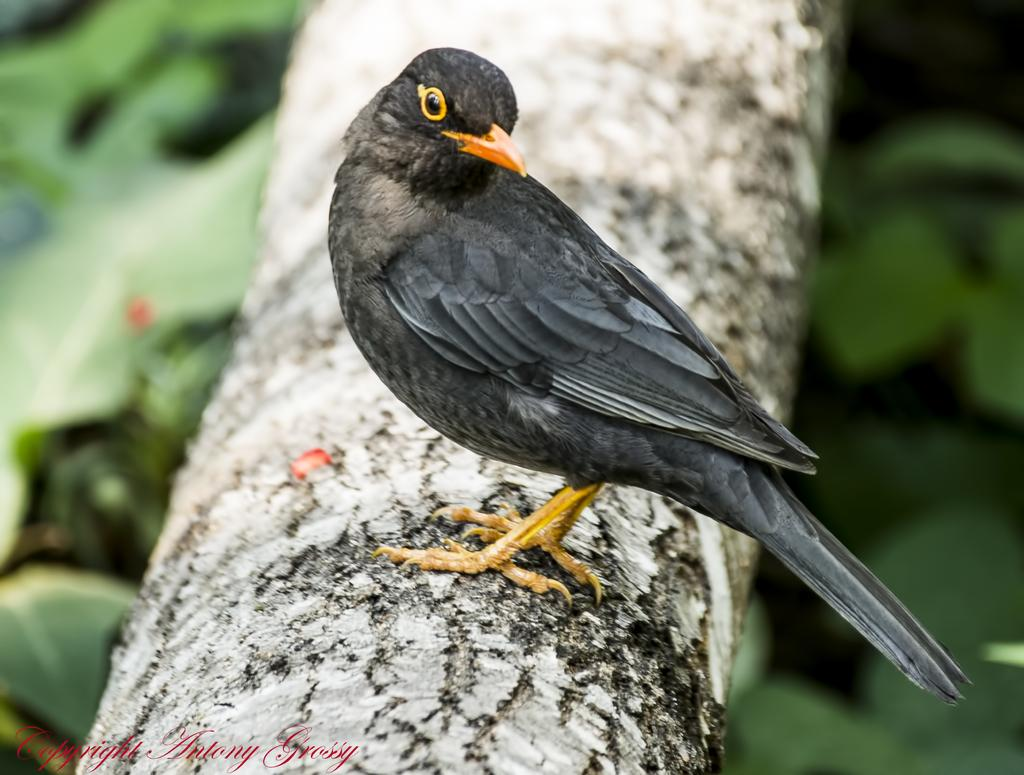What type of animal can be seen in the image? There is a bird in the image. Where is the bird located? The bird is on a log. What color is the background of the image? The background of the image is blue. What type of vegetation can be seen in the background? There is greenery in the background of the image. Reasoning: Let'g: Let's think step by step in order to produce the conversation. We start by identifying the main subject in the image, which is the bird. Then, we describe the bird's location and the background of the image, including its color and the presence of greenery. Each question is designed to elicit a specific detail about the image that is known from the provided facts. Absurd Question/Answer: Where is the pen located in the image? There is no pen present in the image. What type of bird is sitting on the shelf in the image? There is no shelf or bird of that type in the image. What type of bird is sitting on the shelf in the image? There is no shelf or bird of that type in the image. How many pens are visible on the table in the image? There is no table or pen present in the image. 